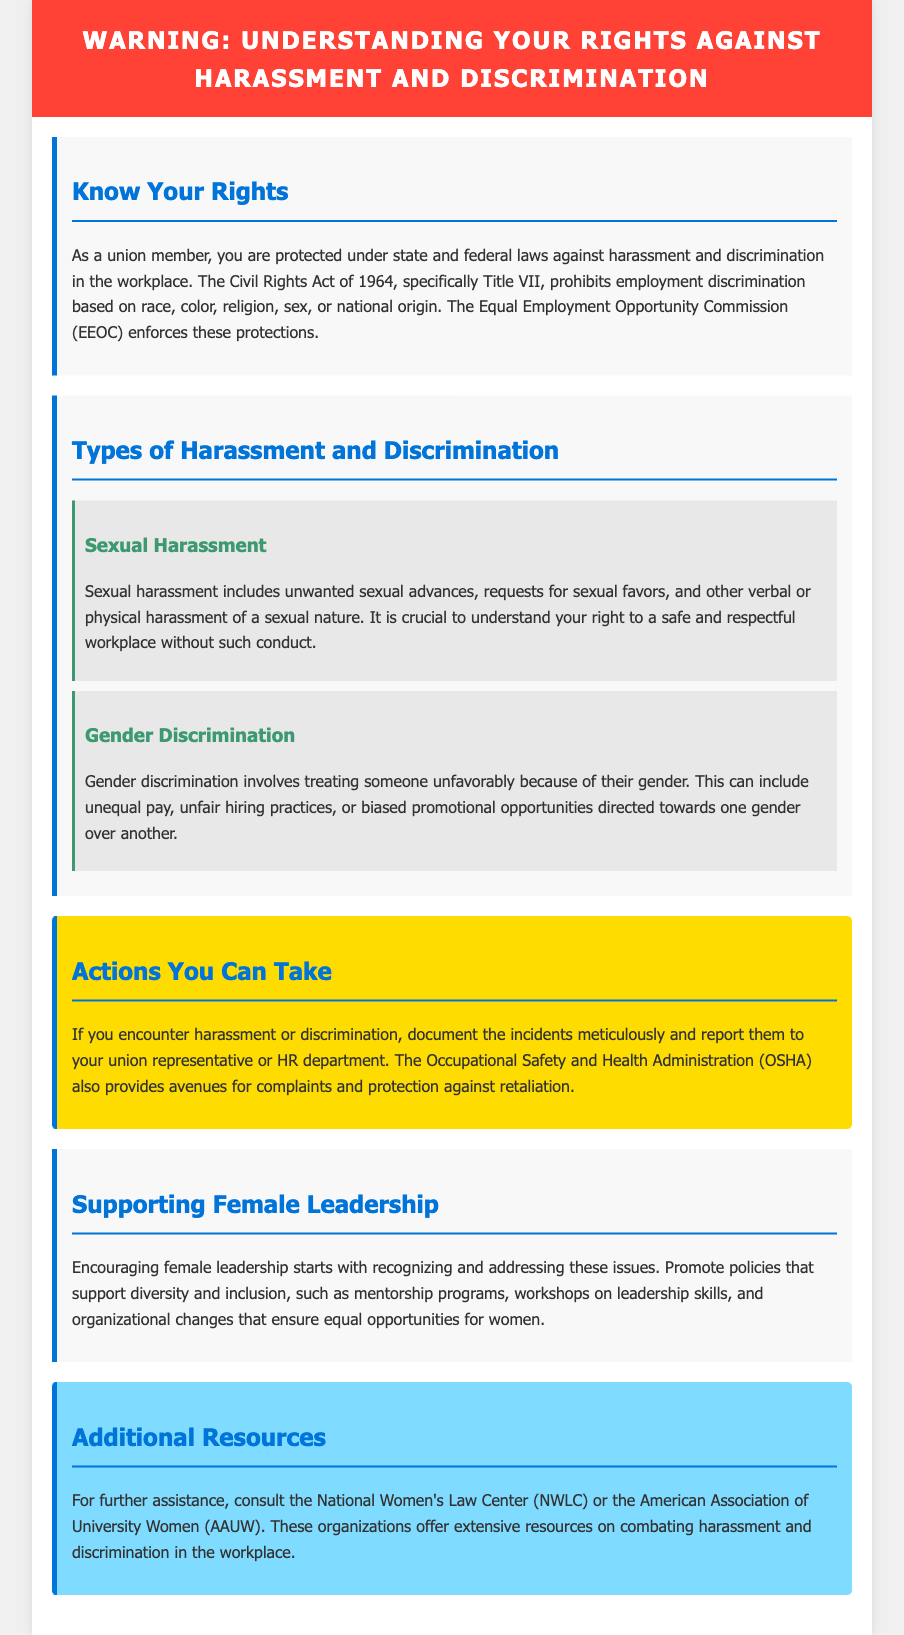What federal act protects against workplace discrimination? The document states that the Civil Rights Act of 1964 prohibits employment discrimination.
Answer: Civil Rights Act of 1964 What is one type of harassment mentioned in the document? The document specifies several types, including sexual harassment as a key example.
Answer: Sexual harassment What can you do if you encounter harassment at work? The document suggests that you document incidents and report them to your union representative or HR department.
Answer: Document and report Which organization offers avenues for complaints related to workplace safety? The document mentions OSHA as a resource for complaints regarding harassment and discrimination.
Answer: OSHA What does the section on supporting female leadership promote? The document highlights the importance of promoting diversity and inclusion policies, such as mentorship programs.
Answer: Mentorship programs What section discusses federal laws regarding workplace discrimination? The "Know Your Rights" section discusses protections under federal laws against harassment and discrimination.
Answer: Know Your Rights Who enforces the protections against employment discrimination mentioned in the document? The Equal Employment Opportunity Commission (EEOC) is named as the enforcing body in the document.
Answer: EEOC What type of discrimination involves unequal pay based on gender? The document specifies gender discrimination as treating someone unfavorably due to their gender.
Answer: Gender discrimination 